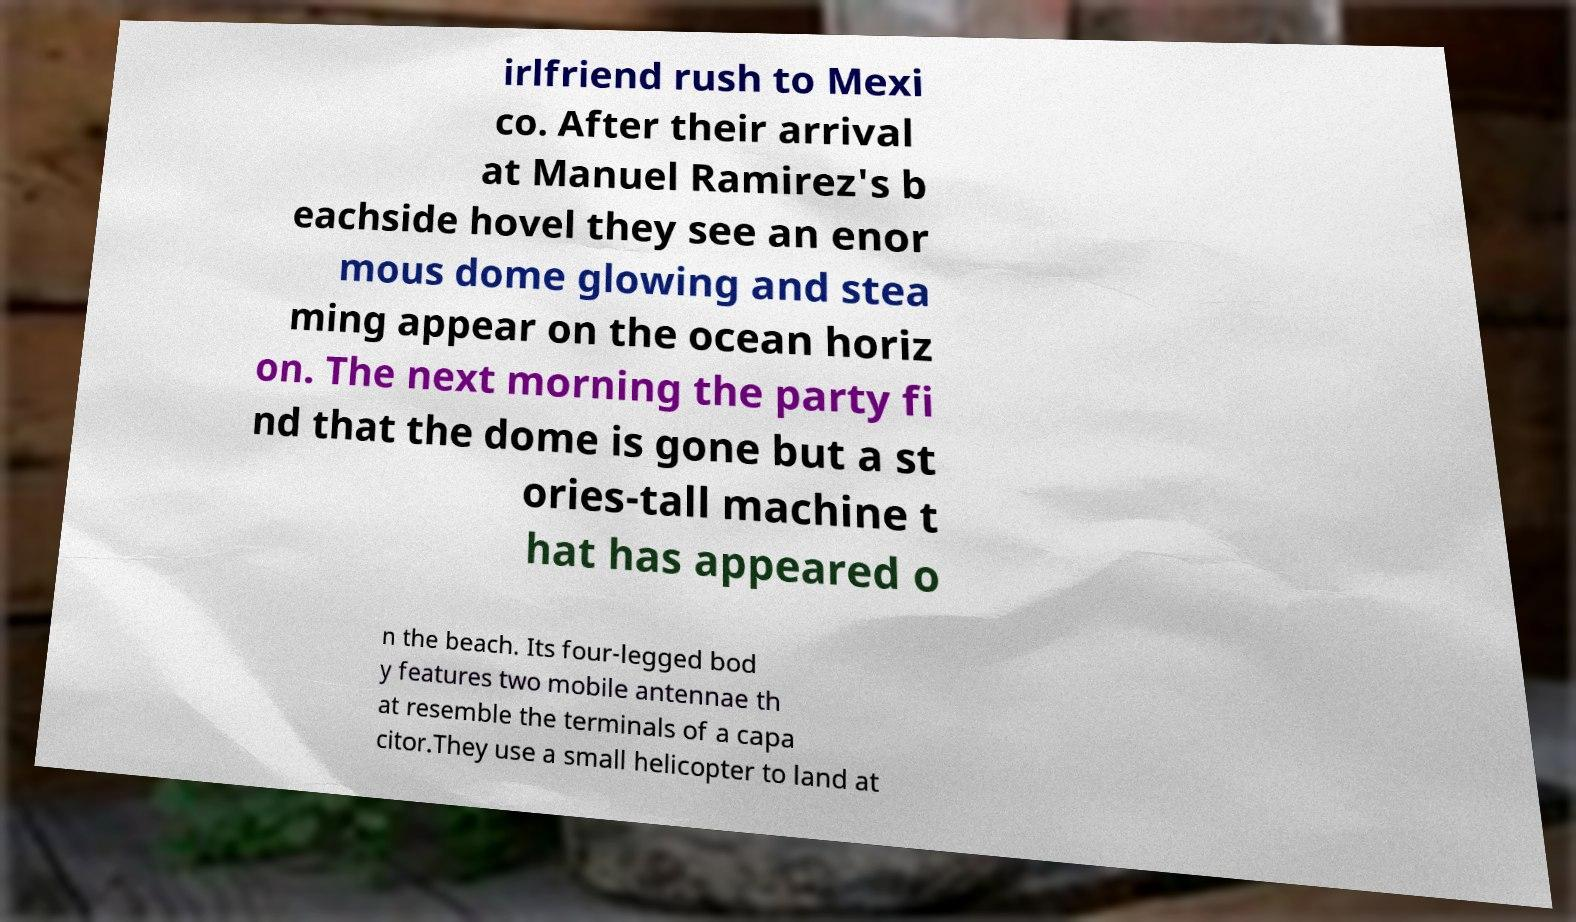There's text embedded in this image that I need extracted. Can you transcribe it verbatim? irlfriend rush to Mexi co. After their arrival at Manuel Ramirez's b eachside hovel they see an enor mous dome glowing and stea ming appear on the ocean horiz on. The next morning the party fi nd that the dome is gone but a st ories-tall machine t hat has appeared o n the beach. Its four-legged bod y features two mobile antennae th at resemble the terminals of a capa citor.They use a small helicopter to land at 